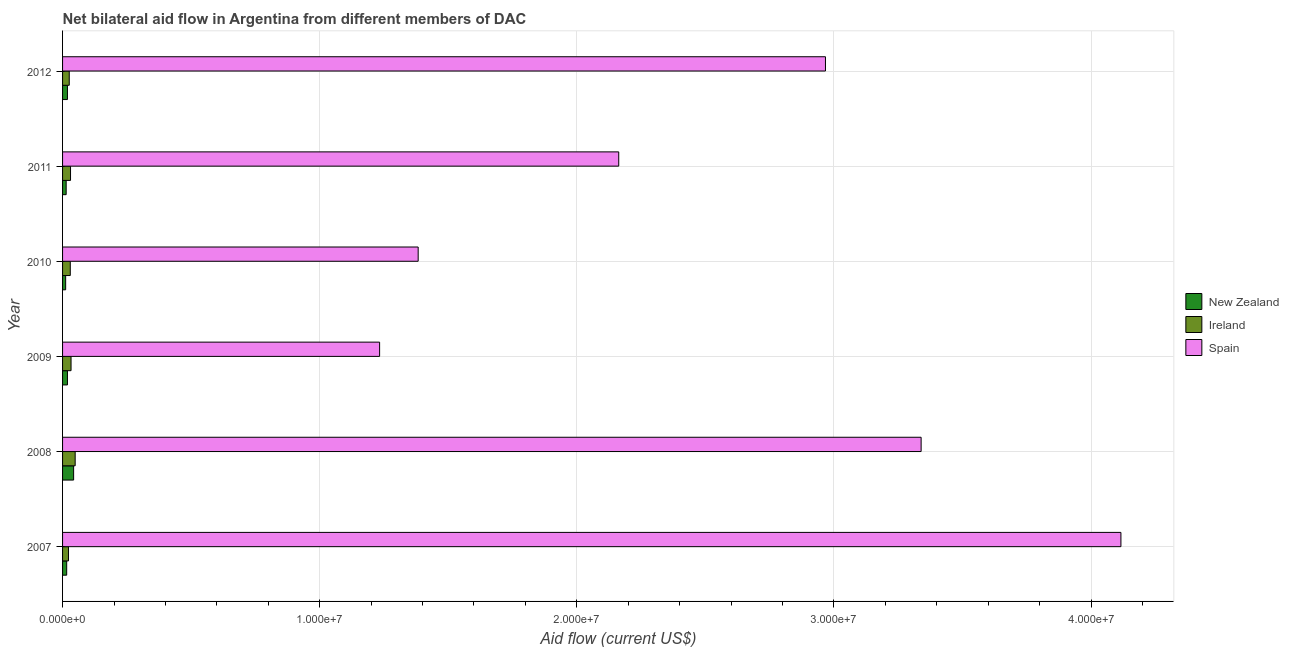How many different coloured bars are there?
Offer a terse response. 3. How many bars are there on the 1st tick from the top?
Your answer should be compact. 3. How many bars are there on the 2nd tick from the bottom?
Ensure brevity in your answer.  3. What is the label of the 3rd group of bars from the top?
Provide a succinct answer. 2010. What is the amount of aid provided by ireland in 2010?
Keep it short and to the point. 3.00e+05. Across all years, what is the maximum amount of aid provided by ireland?
Provide a succinct answer. 4.90e+05. Across all years, what is the minimum amount of aid provided by spain?
Offer a very short reply. 1.23e+07. What is the total amount of aid provided by ireland in the graph?
Ensure brevity in your answer.  1.92e+06. What is the difference between the amount of aid provided by ireland in 2007 and that in 2009?
Your answer should be very brief. -1.00e+05. What is the difference between the amount of aid provided by ireland in 2009 and the amount of aid provided by new zealand in 2011?
Your answer should be compact. 1.90e+05. What is the average amount of aid provided by new zealand per year?
Offer a terse response. 2.05e+05. In the year 2010, what is the difference between the amount of aid provided by ireland and amount of aid provided by spain?
Provide a succinct answer. -1.35e+07. What is the ratio of the amount of aid provided by new zealand in 2008 to that in 2011?
Your answer should be compact. 3.07. Is the amount of aid provided by ireland in 2007 less than that in 2012?
Provide a succinct answer. Yes. Is the difference between the amount of aid provided by spain in 2007 and 2012 greater than the difference between the amount of aid provided by ireland in 2007 and 2012?
Make the answer very short. Yes. What is the difference between the highest and the lowest amount of aid provided by spain?
Your answer should be very brief. 2.88e+07. In how many years, is the amount of aid provided by spain greater than the average amount of aid provided by spain taken over all years?
Make the answer very short. 3. Is the sum of the amount of aid provided by spain in 2007 and 2008 greater than the maximum amount of aid provided by ireland across all years?
Offer a very short reply. Yes. What does the 2nd bar from the top in 2012 represents?
Give a very brief answer. Ireland. What does the 1st bar from the bottom in 2007 represents?
Provide a succinct answer. New Zealand. Is it the case that in every year, the sum of the amount of aid provided by new zealand and amount of aid provided by ireland is greater than the amount of aid provided by spain?
Make the answer very short. No. Are the values on the major ticks of X-axis written in scientific E-notation?
Ensure brevity in your answer.  Yes. Where does the legend appear in the graph?
Keep it short and to the point. Center right. What is the title of the graph?
Make the answer very short. Net bilateral aid flow in Argentina from different members of DAC. What is the label or title of the X-axis?
Ensure brevity in your answer.  Aid flow (current US$). What is the label or title of the Y-axis?
Give a very brief answer. Year. What is the Aid flow (current US$) in New Zealand in 2007?
Offer a terse response. 1.60e+05. What is the Aid flow (current US$) of Ireland in 2007?
Your response must be concise. 2.30e+05. What is the Aid flow (current US$) in Spain in 2007?
Give a very brief answer. 4.12e+07. What is the Aid flow (current US$) in Spain in 2008?
Provide a short and direct response. 3.34e+07. What is the Aid flow (current US$) in Ireland in 2009?
Give a very brief answer. 3.30e+05. What is the Aid flow (current US$) in Spain in 2009?
Provide a succinct answer. 1.23e+07. What is the Aid flow (current US$) of New Zealand in 2010?
Offer a very short reply. 1.20e+05. What is the Aid flow (current US$) of Ireland in 2010?
Offer a very short reply. 3.00e+05. What is the Aid flow (current US$) in Spain in 2010?
Keep it short and to the point. 1.38e+07. What is the Aid flow (current US$) of Spain in 2011?
Your response must be concise. 2.16e+07. What is the Aid flow (current US$) in Ireland in 2012?
Your answer should be very brief. 2.60e+05. What is the Aid flow (current US$) in Spain in 2012?
Keep it short and to the point. 2.97e+07. Across all years, what is the maximum Aid flow (current US$) of New Zealand?
Your answer should be compact. 4.30e+05. Across all years, what is the maximum Aid flow (current US$) of Spain?
Provide a succinct answer. 4.12e+07. Across all years, what is the minimum Aid flow (current US$) in New Zealand?
Offer a terse response. 1.20e+05. Across all years, what is the minimum Aid flow (current US$) of Spain?
Your answer should be very brief. 1.23e+07. What is the total Aid flow (current US$) in New Zealand in the graph?
Your response must be concise. 1.23e+06. What is the total Aid flow (current US$) in Ireland in the graph?
Provide a short and direct response. 1.92e+06. What is the total Aid flow (current US$) of Spain in the graph?
Provide a short and direct response. 1.52e+08. What is the difference between the Aid flow (current US$) in New Zealand in 2007 and that in 2008?
Your answer should be very brief. -2.70e+05. What is the difference between the Aid flow (current US$) of Spain in 2007 and that in 2008?
Make the answer very short. 7.77e+06. What is the difference between the Aid flow (current US$) in New Zealand in 2007 and that in 2009?
Offer a terse response. -3.00e+04. What is the difference between the Aid flow (current US$) of Spain in 2007 and that in 2009?
Your answer should be very brief. 2.88e+07. What is the difference between the Aid flow (current US$) in Ireland in 2007 and that in 2010?
Your response must be concise. -7.00e+04. What is the difference between the Aid flow (current US$) of Spain in 2007 and that in 2010?
Provide a short and direct response. 2.73e+07. What is the difference between the Aid flow (current US$) in Spain in 2007 and that in 2011?
Your response must be concise. 1.95e+07. What is the difference between the Aid flow (current US$) in Spain in 2007 and that in 2012?
Give a very brief answer. 1.15e+07. What is the difference between the Aid flow (current US$) of Spain in 2008 and that in 2009?
Ensure brevity in your answer.  2.11e+07. What is the difference between the Aid flow (current US$) in Spain in 2008 and that in 2010?
Ensure brevity in your answer.  1.96e+07. What is the difference between the Aid flow (current US$) of Ireland in 2008 and that in 2011?
Make the answer very short. 1.80e+05. What is the difference between the Aid flow (current US$) in Spain in 2008 and that in 2011?
Keep it short and to the point. 1.18e+07. What is the difference between the Aid flow (current US$) in New Zealand in 2008 and that in 2012?
Make the answer very short. 2.40e+05. What is the difference between the Aid flow (current US$) in Ireland in 2008 and that in 2012?
Give a very brief answer. 2.30e+05. What is the difference between the Aid flow (current US$) in Spain in 2008 and that in 2012?
Your answer should be compact. 3.72e+06. What is the difference between the Aid flow (current US$) of Ireland in 2009 and that in 2010?
Your answer should be compact. 3.00e+04. What is the difference between the Aid flow (current US$) of Spain in 2009 and that in 2010?
Offer a very short reply. -1.50e+06. What is the difference between the Aid flow (current US$) of New Zealand in 2009 and that in 2011?
Your answer should be very brief. 5.00e+04. What is the difference between the Aid flow (current US$) of Ireland in 2009 and that in 2011?
Your answer should be very brief. 2.00e+04. What is the difference between the Aid flow (current US$) in Spain in 2009 and that in 2011?
Your answer should be compact. -9.30e+06. What is the difference between the Aid flow (current US$) in New Zealand in 2009 and that in 2012?
Offer a terse response. 0. What is the difference between the Aid flow (current US$) in Spain in 2009 and that in 2012?
Offer a terse response. -1.73e+07. What is the difference between the Aid flow (current US$) in New Zealand in 2010 and that in 2011?
Your answer should be compact. -2.00e+04. What is the difference between the Aid flow (current US$) in Spain in 2010 and that in 2011?
Make the answer very short. -7.80e+06. What is the difference between the Aid flow (current US$) in New Zealand in 2010 and that in 2012?
Your answer should be compact. -7.00e+04. What is the difference between the Aid flow (current US$) in Spain in 2010 and that in 2012?
Your answer should be compact. -1.58e+07. What is the difference between the Aid flow (current US$) of New Zealand in 2011 and that in 2012?
Offer a terse response. -5.00e+04. What is the difference between the Aid flow (current US$) of Ireland in 2011 and that in 2012?
Provide a succinct answer. 5.00e+04. What is the difference between the Aid flow (current US$) of Spain in 2011 and that in 2012?
Your answer should be compact. -8.04e+06. What is the difference between the Aid flow (current US$) of New Zealand in 2007 and the Aid flow (current US$) of Ireland in 2008?
Provide a succinct answer. -3.30e+05. What is the difference between the Aid flow (current US$) of New Zealand in 2007 and the Aid flow (current US$) of Spain in 2008?
Give a very brief answer. -3.32e+07. What is the difference between the Aid flow (current US$) in Ireland in 2007 and the Aid flow (current US$) in Spain in 2008?
Your response must be concise. -3.32e+07. What is the difference between the Aid flow (current US$) in New Zealand in 2007 and the Aid flow (current US$) in Ireland in 2009?
Make the answer very short. -1.70e+05. What is the difference between the Aid flow (current US$) of New Zealand in 2007 and the Aid flow (current US$) of Spain in 2009?
Offer a very short reply. -1.22e+07. What is the difference between the Aid flow (current US$) of Ireland in 2007 and the Aid flow (current US$) of Spain in 2009?
Keep it short and to the point. -1.21e+07. What is the difference between the Aid flow (current US$) in New Zealand in 2007 and the Aid flow (current US$) in Ireland in 2010?
Offer a very short reply. -1.40e+05. What is the difference between the Aid flow (current US$) in New Zealand in 2007 and the Aid flow (current US$) in Spain in 2010?
Give a very brief answer. -1.37e+07. What is the difference between the Aid flow (current US$) of Ireland in 2007 and the Aid flow (current US$) of Spain in 2010?
Ensure brevity in your answer.  -1.36e+07. What is the difference between the Aid flow (current US$) of New Zealand in 2007 and the Aid flow (current US$) of Ireland in 2011?
Provide a short and direct response. -1.50e+05. What is the difference between the Aid flow (current US$) in New Zealand in 2007 and the Aid flow (current US$) in Spain in 2011?
Ensure brevity in your answer.  -2.15e+07. What is the difference between the Aid flow (current US$) in Ireland in 2007 and the Aid flow (current US$) in Spain in 2011?
Your response must be concise. -2.14e+07. What is the difference between the Aid flow (current US$) in New Zealand in 2007 and the Aid flow (current US$) in Spain in 2012?
Offer a very short reply. -2.95e+07. What is the difference between the Aid flow (current US$) of Ireland in 2007 and the Aid flow (current US$) of Spain in 2012?
Provide a short and direct response. -2.94e+07. What is the difference between the Aid flow (current US$) in New Zealand in 2008 and the Aid flow (current US$) in Ireland in 2009?
Provide a short and direct response. 1.00e+05. What is the difference between the Aid flow (current US$) of New Zealand in 2008 and the Aid flow (current US$) of Spain in 2009?
Provide a short and direct response. -1.19e+07. What is the difference between the Aid flow (current US$) in Ireland in 2008 and the Aid flow (current US$) in Spain in 2009?
Provide a short and direct response. -1.18e+07. What is the difference between the Aid flow (current US$) in New Zealand in 2008 and the Aid flow (current US$) in Spain in 2010?
Provide a succinct answer. -1.34e+07. What is the difference between the Aid flow (current US$) of Ireland in 2008 and the Aid flow (current US$) of Spain in 2010?
Keep it short and to the point. -1.33e+07. What is the difference between the Aid flow (current US$) of New Zealand in 2008 and the Aid flow (current US$) of Ireland in 2011?
Your answer should be compact. 1.20e+05. What is the difference between the Aid flow (current US$) in New Zealand in 2008 and the Aid flow (current US$) in Spain in 2011?
Provide a succinct answer. -2.12e+07. What is the difference between the Aid flow (current US$) of Ireland in 2008 and the Aid flow (current US$) of Spain in 2011?
Offer a very short reply. -2.11e+07. What is the difference between the Aid flow (current US$) of New Zealand in 2008 and the Aid flow (current US$) of Spain in 2012?
Your response must be concise. -2.92e+07. What is the difference between the Aid flow (current US$) of Ireland in 2008 and the Aid flow (current US$) of Spain in 2012?
Your answer should be compact. -2.92e+07. What is the difference between the Aid flow (current US$) of New Zealand in 2009 and the Aid flow (current US$) of Spain in 2010?
Your response must be concise. -1.36e+07. What is the difference between the Aid flow (current US$) in Ireland in 2009 and the Aid flow (current US$) in Spain in 2010?
Make the answer very short. -1.35e+07. What is the difference between the Aid flow (current US$) of New Zealand in 2009 and the Aid flow (current US$) of Ireland in 2011?
Provide a short and direct response. -1.20e+05. What is the difference between the Aid flow (current US$) of New Zealand in 2009 and the Aid flow (current US$) of Spain in 2011?
Offer a very short reply. -2.14e+07. What is the difference between the Aid flow (current US$) of Ireland in 2009 and the Aid flow (current US$) of Spain in 2011?
Your response must be concise. -2.13e+07. What is the difference between the Aid flow (current US$) in New Zealand in 2009 and the Aid flow (current US$) in Ireland in 2012?
Keep it short and to the point. -7.00e+04. What is the difference between the Aid flow (current US$) in New Zealand in 2009 and the Aid flow (current US$) in Spain in 2012?
Offer a terse response. -2.95e+07. What is the difference between the Aid flow (current US$) of Ireland in 2009 and the Aid flow (current US$) of Spain in 2012?
Keep it short and to the point. -2.93e+07. What is the difference between the Aid flow (current US$) in New Zealand in 2010 and the Aid flow (current US$) in Spain in 2011?
Give a very brief answer. -2.15e+07. What is the difference between the Aid flow (current US$) of Ireland in 2010 and the Aid flow (current US$) of Spain in 2011?
Provide a short and direct response. -2.13e+07. What is the difference between the Aid flow (current US$) in New Zealand in 2010 and the Aid flow (current US$) in Spain in 2012?
Make the answer very short. -2.96e+07. What is the difference between the Aid flow (current US$) in Ireland in 2010 and the Aid flow (current US$) in Spain in 2012?
Make the answer very short. -2.94e+07. What is the difference between the Aid flow (current US$) of New Zealand in 2011 and the Aid flow (current US$) of Ireland in 2012?
Your answer should be very brief. -1.20e+05. What is the difference between the Aid flow (current US$) of New Zealand in 2011 and the Aid flow (current US$) of Spain in 2012?
Offer a very short reply. -2.95e+07. What is the difference between the Aid flow (current US$) in Ireland in 2011 and the Aid flow (current US$) in Spain in 2012?
Your response must be concise. -2.94e+07. What is the average Aid flow (current US$) in New Zealand per year?
Give a very brief answer. 2.05e+05. What is the average Aid flow (current US$) of Spain per year?
Keep it short and to the point. 2.53e+07. In the year 2007, what is the difference between the Aid flow (current US$) of New Zealand and Aid flow (current US$) of Ireland?
Give a very brief answer. -7.00e+04. In the year 2007, what is the difference between the Aid flow (current US$) in New Zealand and Aid flow (current US$) in Spain?
Give a very brief answer. -4.10e+07. In the year 2007, what is the difference between the Aid flow (current US$) of Ireland and Aid flow (current US$) of Spain?
Make the answer very short. -4.09e+07. In the year 2008, what is the difference between the Aid flow (current US$) in New Zealand and Aid flow (current US$) in Ireland?
Your answer should be very brief. -6.00e+04. In the year 2008, what is the difference between the Aid flow (current US$) of New Zealand and Aid flow (current US$) of Spain?
Give a very brief answer. -3.30e+07. In the year 2008, what is the difference between the Aid flow (current US$) of Ireland and Aid flow (current US$) of Spain?
Offer a terse response. -3.29e+07. In the year 2009, what is the difference between the Aid flow (current US$) of New Zealand and Aid flow (current US$) of Spain?
Your response must be concise. -1.21e+07. In the year 2009, what is the difference between the Aid flow (current US$) in Ireland and Aid flow (current US$) in Spain?
Offer a very short reply. -1.20e+07. In the year 2010, what is the difference between the Aid flow (current US$) of New Zealand and Aid flow (current US$) of Ireland?
Your answer should be very brief. -1.80e+05. In the year 2010, what is the difference between the Aid flow (current US$) of New Zealand and Aid flow (current US$) of Spain?
Give a very brief answer. -1.37e+07. In the year 2010, what is the difference between the Aid flow (current US$) of Ireland and Aid flow (current US$) of Spain?
Offer a terse response. -1.35e+07. In the year 2011, what is the difference between the Aid flow (current US$) of New Zealand and Aid flow (current US$) of Spain?
Make the answer very short. -2.15e+07. In the year 2011, what is the difference between the Aid flow (current US$) in Ireland and Aid flow (current US$) in Spain?
Your answer should be compact. -2.13e+07. In the year 2012, what is the difference between the Aid flow (current US$) of New Zealand and Aid flow (current US$) of Ireland?
Make the answer very short. -7.00e+04. In the year 2012, what is the difference between the Aid flow (current US$) of New Zealand and Aid flow (current US$) of Spain?
Ensure brevity in your answer.  -2.95e+07. In the year 2012, what is the difference between the Aid flow (current US$) of Ireland and Aid flow (current US$) of Spain?
Ensure brevity in your answer.  -2.94e+07. What is the ratio of the Aid flow (current US$) in New Zealand in 2007 to that in 2008?
Provide a succinct answer. 0.37. What is the ratio of the Aid flow (current US$) of Ireland in 2007 to that in 2008?
Provide a short and direct response. 0.47. What is the ratio of the Aid flow (current US$) of Spain in 2007 to that in 2008?
Make the answer very short. 1.23. What is the ratio of the Aid flow (current US$) of New Zealand in 2007 to that in 2009?
Keep it short and to the point. 0.84. What is the ratio of the Aid flow (current US$) of Ireland in 2007 to that in 2009?
Make the answer very short. 0.7. What is the ratio of the Aid flow (current US$) of Spain in 2007 to that in 2009?
Make the answer very short. 3.34. What is the ratio of the Aid flow (current US$) of New Zealand in 2007 to that in 2010?
Your answer should be very brief. 1.33. What is the ratio of the Aid flow (current US$) of Ireland in 2007 to that in 2010?
Ensure brevity in your answer.  0.77. What is the ratio of the Aid flow (current US$) in Spain in 2007 to that in 2010?
Provide a short and direct response. 2.98. What is the ratio of the Aid flow (current US$) in New Zealand in 2007 to that in 2011?
Ensure brevity in your answer.  1.14. What is the ratio of the Aid flow (current US$) in Ireland in 2007 to that in 2011?
Your response must be concise. 0.74. What is the ratio of the Aid flow (current US$) of Spain in 2007 to that in 2011?
Your response must be concise. 1.9. What is the ratio of the Aid flow (current US$) in New Zealand in 2007 to that in 2012?
Keep it short and to the point. 0.84. What is the ratio of the Aid flow (current US$) of Ireland in 2007 to that in 2012?
Offer a terse response. 0.88. What is the ratio of the Aid flow (current US$) of Spain in 2007 to that in 2012?
Your answer should be compact. 1.39. What is the ratio of the Aid flow (current US$) of New Zealand in 2008 to that in 2009?
Your response must be concise. 2.26. What is the ratio of the Aid flow (current US$) of Ireland in 2008 to that in 2009?
Your answer should be compact. 1.48. What is the ratio of the Aid flow (current US$) of Spain in 2008 to that in 2009?
Provide a short and direct response. 2.71. What is the ratio of the Aid flow (current US$) of New Zealand in 2008 to that in 2010?
Your answer should be compact. 3.58. What is the ratio of the Aid flow (current US$) in Ireland in 2008 to that in 2010?
Your answer should be very brief. 1.63. What is the ratio of the Aid flow (current US$) of Spain in 2008 to that in 2010?
Your answer should be very brief. 2.41. What is the ratio of the Aid flow (current US$) in New Zealand in 2008 to that in 2011?
Offer a terse response. 3.07. What is the ratio of the Aid flow (current US$) in Ireland in 2008 to that in 2011?
Provide a short and direct response. 1.58. What is the ratio of the Aid flow (current US$) of Spain in 2008 to that in 2011?
Give a very brief answer. 1.54. What is the ratio of the Aid flow (current US$) in New Zealand in 2008 to that in 2012?
Give a very brief answer. 2.26. What is the ratio of the Aid flow (current US$) of Ireland in 2008 to that in 2012?
Keep it short and to the point. 1.88. What is the ratio of the Aid flow (current US$) of Spain in 2008 to that in 2012?
Make the answer very short. 1.13. What is the ratio of the Aid flow (current US$) of New Zealand in 2009 to that in 2010?
Your response must be concise. 1.58. What is the ratio of the Aid flow (current US$) of Ireland in 2009 to that in 2010?
Ensure brevity in your answer.  1.1. What is the ratio of the Aid flow (current US$) of Spain in 2009 to that in 2010?
Provide a short and direct response. 0.89. What is the ratio of the Aid flow (current US$) in New Zealand in 2009 to that in 2011?
Give a very brief answer. 1.36. What is the ratio of the Aid flow (current US$) of Ireland in 2009 to that in 2011?
Make the answer very short. 1.06. What is the ratio of the Aid flow (current US$) of Spain in 2009 to that in 2011?
Offer a terse response. 0.57. What is the ratio of the Aid flow (current US$) of Ireland in 2009 to that in 2012?
Provide a succinct answer. 1.27. What is the ratio of the Aid flow (current US$) in Spain in 2009 to that in 2012?
Provide a short and direct response. 0.42. What is the ratio of the Aid flow (current US$) in New Zealand in 2010 to that in 2011?
Keep it short and to the point. 0.86. What is the ratio of the Aid flow (current US$) in Ireland in 2010 to that in 2011?
Provide a succinct answer. 0.97. What is the ratio of the Aid flow (current US$) in Spain in 2010 to that in 2011?
Give a very brief answer. 0.64. What is the ratio of the Aid flow (current US$) of New Zealand in 2010 to that in 2012?
Provide a succinct answer. 0.63. What is the ratio of the Aid flow (current US$) in Ireland in 2010 to that in 2012?
Offer a terse response. 1.15. What is the ratio of the Aid flow (current US$) in Spain in 2010 to that in 2012?
Give a very brief answer. 0.47. What is the ratio of the Aid flow (current US$) of New Zealand in 2011 to that in 2012?
Provide a succinct answer. 0.74. What is the ratio of the Aid flow (current US$) in Ireland in 2011 to that in 2012?
Keep it short and to the point. 1.19. What is the ratio of the Aid flow (current US$) of Spain in 2011 to that in 2012?
Your response must be concise. 0.73. What is the difference between the highest and the second highest Aid flow (current US$) of Spain?
Your answer should be very brief. 7.77e+06. What is the difference between the highest and the lowest Aid flow (current US$) of New Zealand?
Give a very brief answer. 3.10e+05. What is the difference between the highest and the lowest Aid flow (current US$) in Spain?
Ensure brevity in your answer.  2.88e+07. 